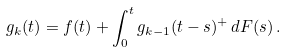<formula> <loc_0><loc_0><loc_500><loc_500>g _ { k } ( t ) = f ( t ) + \int _ { 0 } ^ { t } g _ { k - 1 } ( t - s ) ^ { + } \, d F ( s ) \, .</formula> 